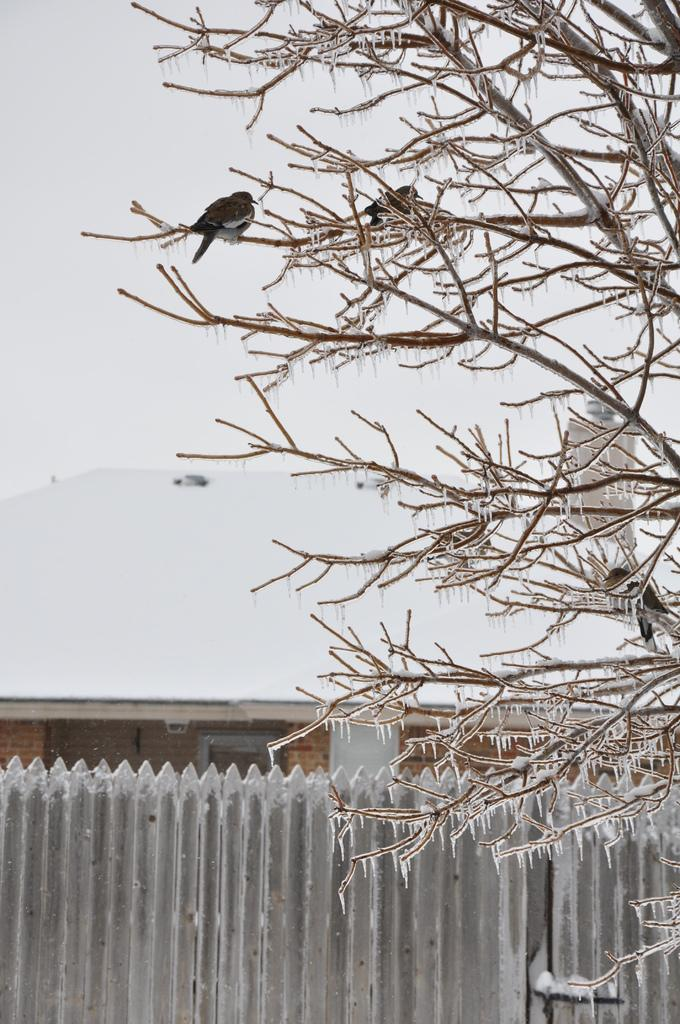What animals can be seen in the image? There are birds on a tree in the image. What type of structure can be seen in the background of the image? There is a shed in the background of the image. What is the purpose of the fence in the image? The purpose of the fence is not explicitly stated, but it could be to mark a boundary or keep animals in or out. What type of wax can be seen melting on the yak in the image? There is no yak or wax present in the image; it features birds on a tree and structures in the background. 